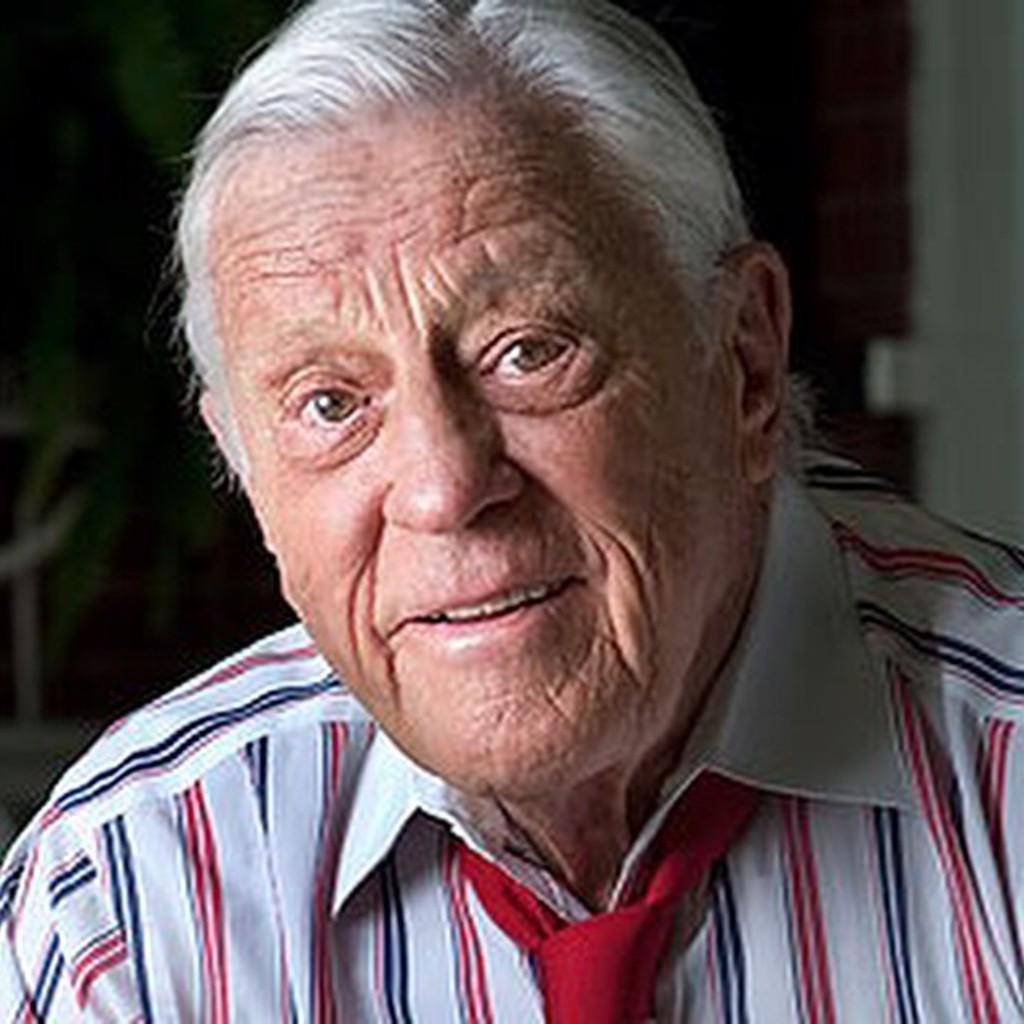How would you summarize this image in a sentence or two? In this picture we can see a old man wearing white shirt with red color strip and red tie, smiling and giving a pose into the camera. Behind we can see a blur background. 